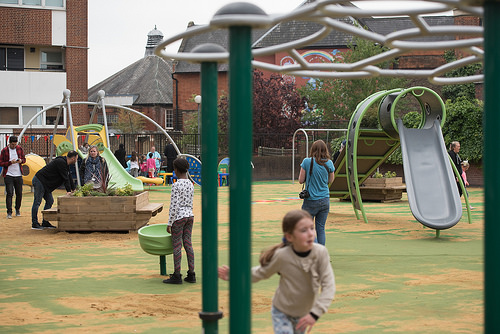<image>
Is the woman on the slide? No. The woman is not positioned on the slide. They may be near each other, but the woman is not supported by or resting on top of the slide. Where is the woman in relation to the girl? Is it on the girl? No. The woman is not positioned on the girl. They may be near each other, but the woman is not supported by or resting on top of the girl. Is there a pole on the kid? No. The pole is not positioned on the kid. They may be near each other, but the pole is not supported by or resting on top of the kid. Where is the woman in relation to the man? Is it to the left of the man? No. The woman is not to the left of the man. From this viewpoint, they have a different horizontal relationship. 